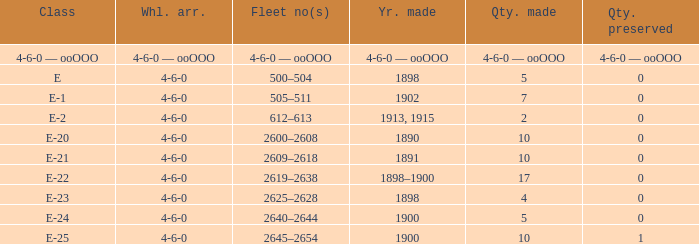What is the fleet number with a 4-6-0 wheel arrangement made in 1890? 2600–2608. 